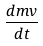Convert formula to latex. <formula><loc_0><loc_0><loc_500><loc_500>\frac { d m v } { d t }</formula> 